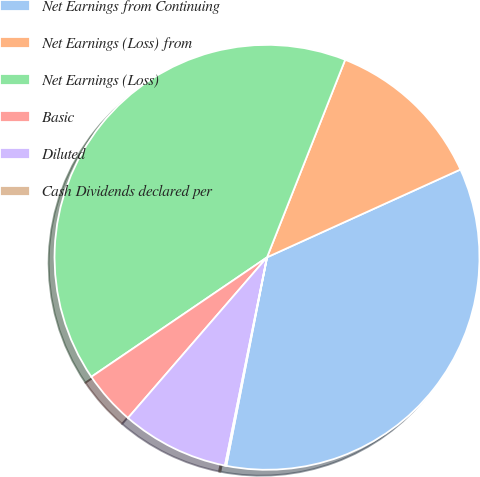Convert chart. <chart><loc_0><loc_0><loc_500><loc_500><pie_chart><fcel>Net Earnings from Continuing<fcel>Net Earnings (Loss) from<fcel>Net Earnings (Loss)<fcel>Basic<fcel>Diluted<fcel>Cash Dividends declared per<nl><fcel>34.85%<fcel>12.22%<fcel>40.5%<fcel>4.14%<fcel>8.18%<fcel>0.1%<nl></chart> 